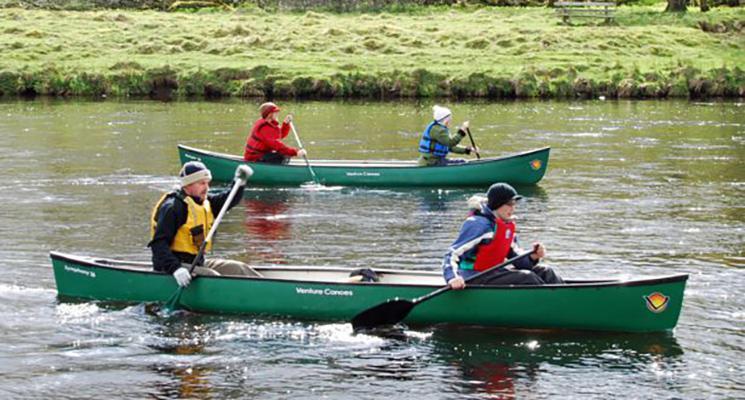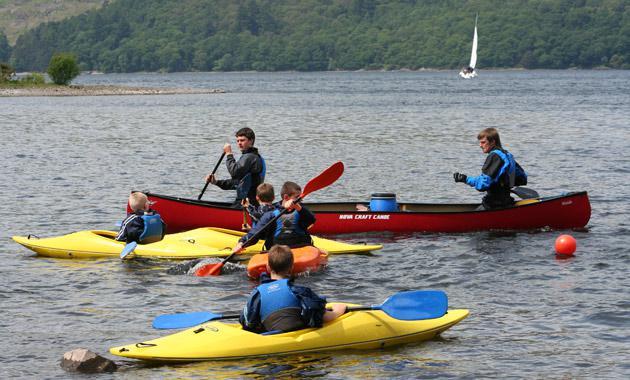The first image is the image on the left, the second image is the image on the right. Analyze the images presented: Is the assertion "One image shows only rowers in red kayaks." valid? Answer yes or no. No. 